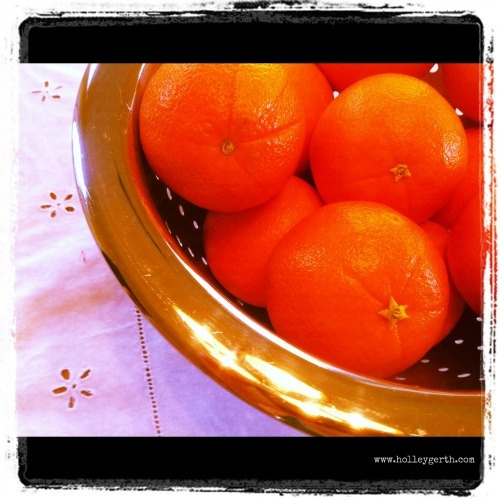Describe the objects in this image and their specific colors. I can see bowl in white, red, and brown tones, orange in white, red, orange, and brown tones, orange in white, red, orange, and brown tones, orange in white, red, and orange tones, and orange in white, red, brown, and maroon tones in this image. 